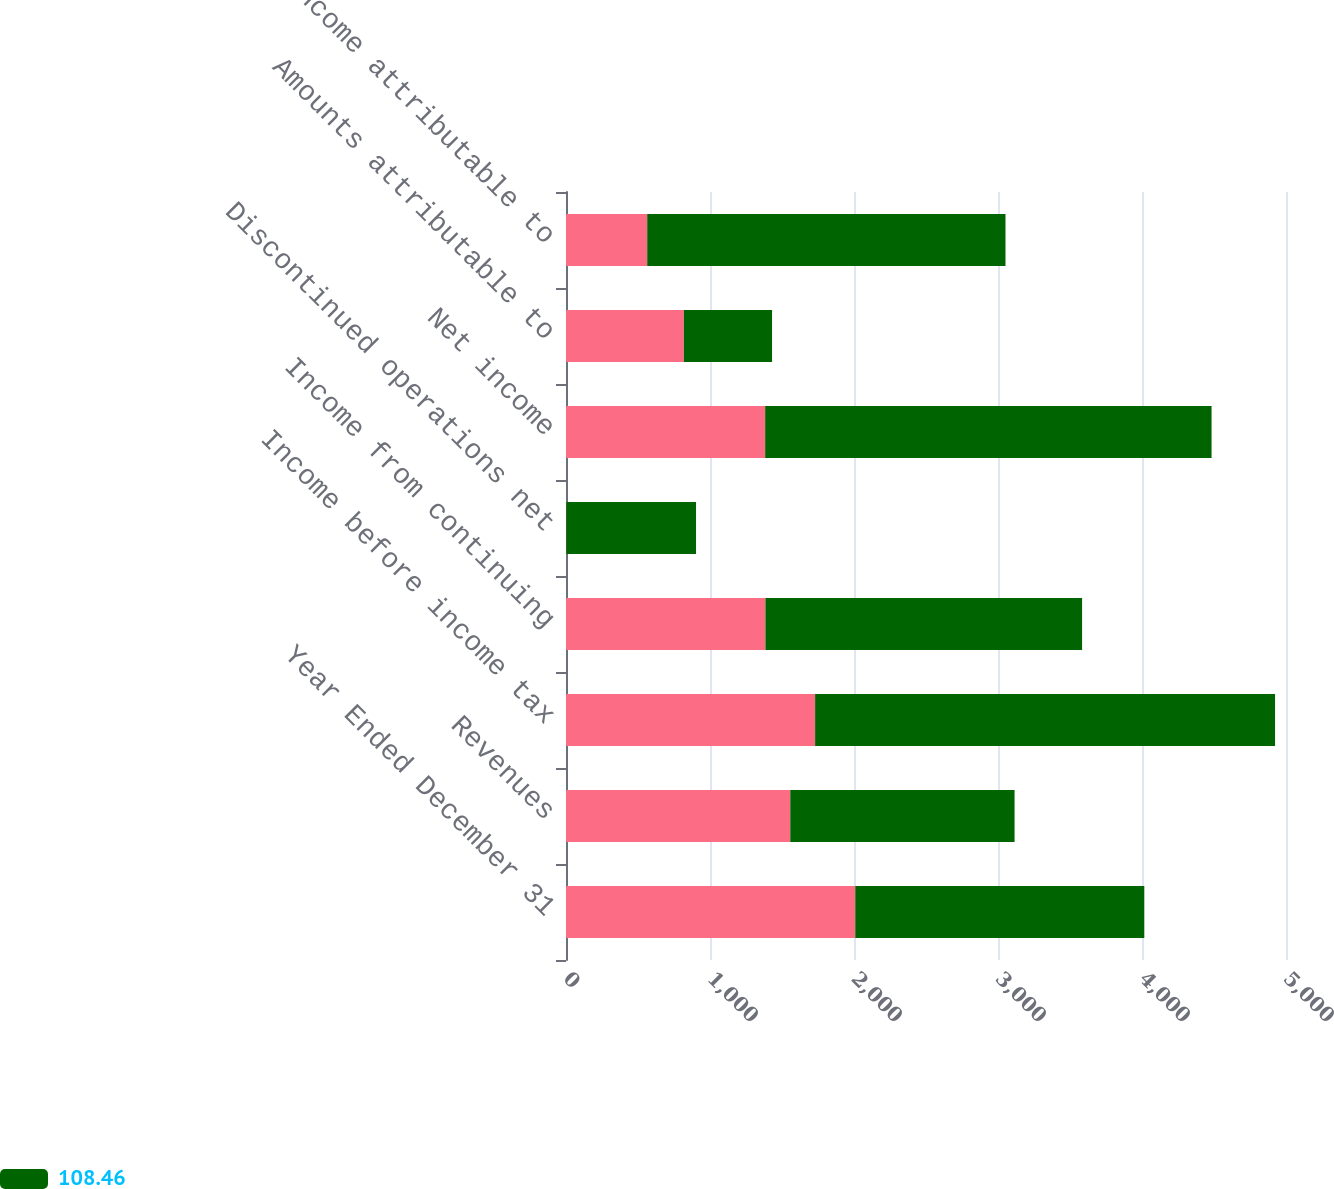<chart> <loc_0><loc_0><loc_500><loc_500><stacked_bar_chart><ecel><fcel>Year Ended December 31<fcel>Revenues<fcel>Income before income tax<fcel>Income from continuing<fcel>Discontinued operations net<fcel>Net income<fcel>Amounts attributable to<fcel>Net income attributable to<nl><fcel>nan<fcel>2009<fcel>1557.5<fcel>1730<fcel>1385<fcel>2<fcel>1383<fcel>819<fcel>564<nl><fcel>108.46<fcel>2007<fcel>1557.5<fcel>3194<fcel>2199<fcel>901<fcel>3100<fcel>612<fcel>2488<nl></chart> 